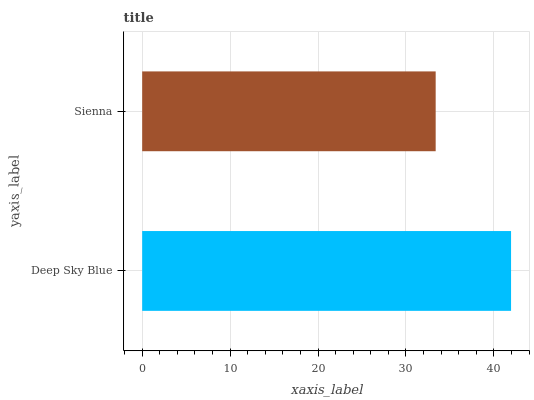Is Sienna the minimum?
Answer yes or no. Yes. Is Deep Sky Blue the maximum?
Answer yes or no. Yes. Is Sienna the maximum?
Answer yes or no. No. Is Deep Sky Blue greater than Sienna?
Answer yes or no. Yes. Is Sienna less than Deep Sky Blue?
Answer yes or no. Yes. Is Sienna greater than Deep Sky Blue?
Answer yes or no. No. Is Deep Sky Blue less than Sienna?
Answer yes or no. No. Is Deep Sky Blue the high median?
Answer yes or no. Yes. Is Sienna the low median?
Answer yes or no. Yes. Is Sienna the high median?
Answer yes or no. No. Is Deep Sky Blue the low median?
Answer yes or no. No. 